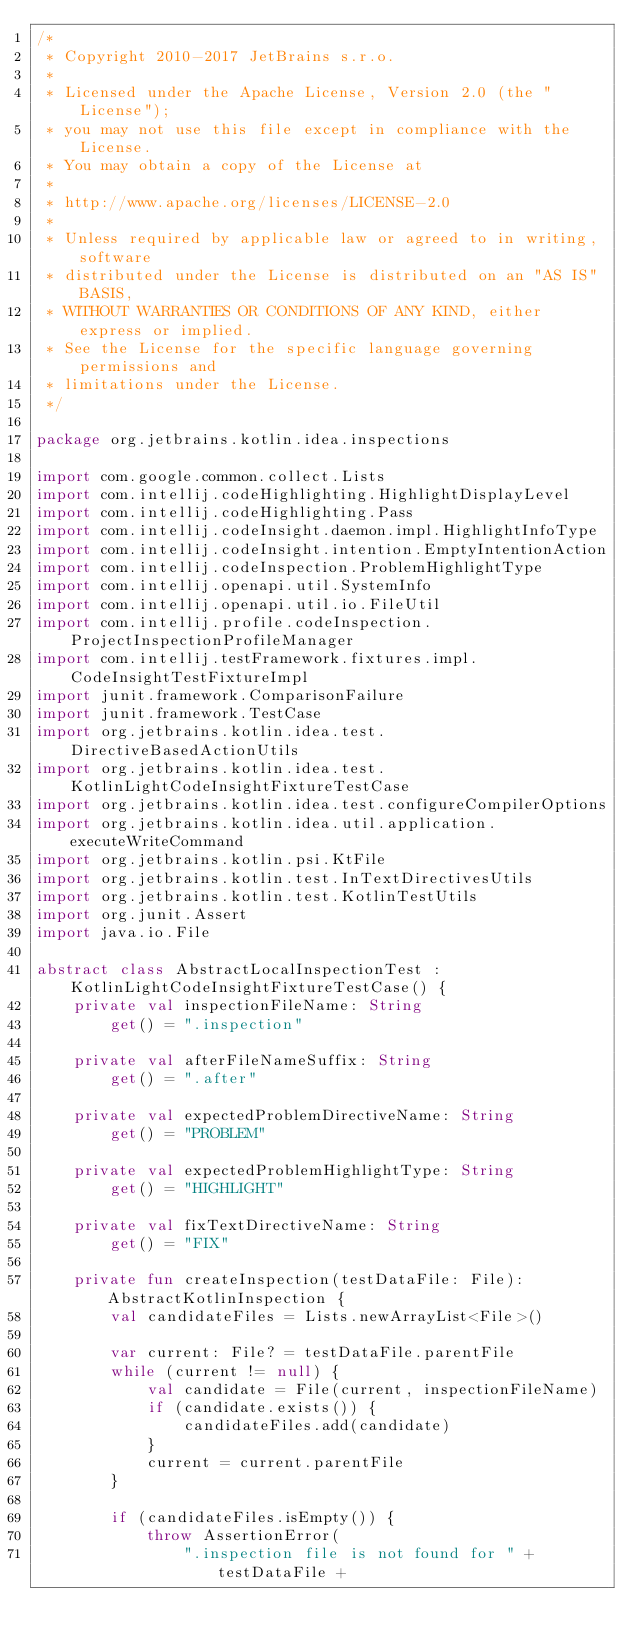Convert code to text. <code><loc_0><loc_0><loc_500><loc_500><_Kotlin_>/*
 * Copyright 2010-2017 JetBrains s.r.o.
 *
 * Licensed under the Apache License, Version 2.0 (the "License");
 * you may not use this file except in compliance with the License.
 * You may obtain a copy of the License at
 *
 * http://www.apache.org/licenses/LICENSE-2.0
 *
 * Unless required by applicable law or agreed to in writing, software
 * distributed under the License is distributed on an "AS IS" BASIS,
 * WITHOUT WARRANTIES OR CONDITIONS OF ANY KIND, either express or implied.
 * See the License for the specific language governing permissions and
 * limitations under the License.
 */

package org.jetbrains.kotlin.idea.inspections

import com.google.common.collect.Lists
import com.intellij.codeHighlighting.HighlightDisplayLevel
import com.intellij.codeHighlighting.Pass
import com.intellij.codeInsight.daemon.impl.HighlightInfoType
import com.intellij.codeInsight.intention.EmptyIntentionAction
import com.intellij.codeInspection.ProblemHighlightType
import com.intellij.openapi.util.SystemInfo
import com.intellij.openapi.util.io.FileUtil
import com.intellij.profile.codeInspection.ProjectInspectionProfileManager
import com.intellij.testFramework.fixtures.impl.CodeInsightTestFixtureImpl
import junit.framework.ComparisonFailure
import junit.framework.TestCase
import org.jetbrains.kotlin.idea.test.DirectiveBasedActionUtils
import org.jetbrains.kotlin.idea.test.KotlinLightCodeInsightFixtureTestCase
import org.jetbrains.kotlin.idea.test.configureCompilerOptions
import org.jetbrains.kotlin.idea.util.application.executeWriteCommand
import org.jetbrains.kotlin.psi.KtFile
import org.jetbrains.kotlin.test.InTextDirectivesUtils
import org.jetbrains.kotlin.test.KotlinTestUtils
import org.junit.Assert
import java.io.File

abstract class AbstractLocalInspectionTest : KotlinLightCodeInsightFixtureTestCase() {
    private val inspectionFileName: String
        get() = ".inspection"

    private val afterFileNameSuffix: String
        get() = ".after"

    private val expectedProblemDirectiveName: String
        get() = "PROBLEM"

    private val expectedProblemHighlightType: String
        get() = "HIGHLIGHT"

    private val fixTextDirectiveName: String
        get() = "FIX"

    private fun createInspection(testDataFile: File): AbstractKotlinInspection {
        val candidateFiles = Lists.newArrayList<File>()

        var current: File? = testDataFile.parentFile
        while (current != null) {
            val candidate = File(current, inspectionFileName)
            if (candidate.exists()) {
                candidateFiles.add(candidate)
            }
            current = current.parentFile
        }

        if (candidateFiles.isEmpty()) {
            throw AssertionError(
                ".inspection file is not found for " + testDataFile +</code> 